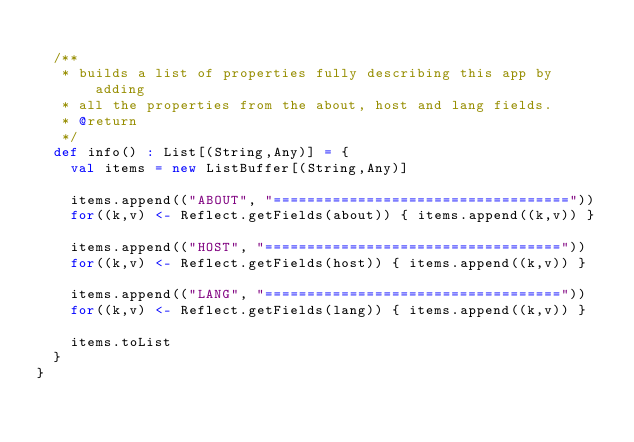Convert code to text. <code><loc_0><loc_0><loc_500><loc_500><_Scala_>
  /**
   * builds a list of properties fully describing this app by adding
   * all the properties from the about, host and lang fields.
   * @return
   */
  def info() : List[(String,Any)] = {
    val items = new ListBuffer[(String,Any)]

    items.append(("ABOUT", "==================================="))
    for((k,v) <- Reflect.getFields(about)) { items.append((k,v)) }

    items.append(("HOST", "==================================="))
    for((k,v) <- Reflect.getFields(host)) { items.append((k,v)) }

    items.append(("LANG", "==================================="))
    for((k,v) <- Reflect.getFields(lang)) { items.append((k,v)) }

    items.toList
  }
}
</code> 